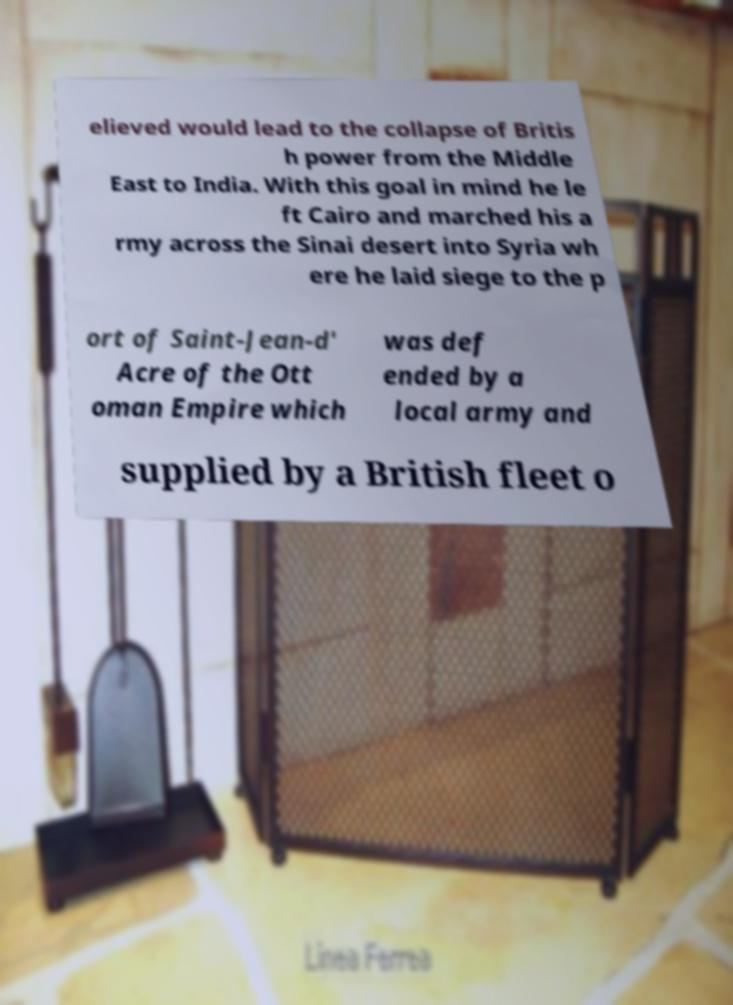Please read and relay the text visible in this image. What does it say? elieved would lead to the collapse of Britis h power from the Middle East to India. With this goal in mind he le ft Cairo and marched his a rmy across the Sinai desert into Syria wh ere he laid siege to the p ort of Saint-Jean-d' Acre of the Ott oman Empire which was def ended by a local army and supplied by a British fleet o 